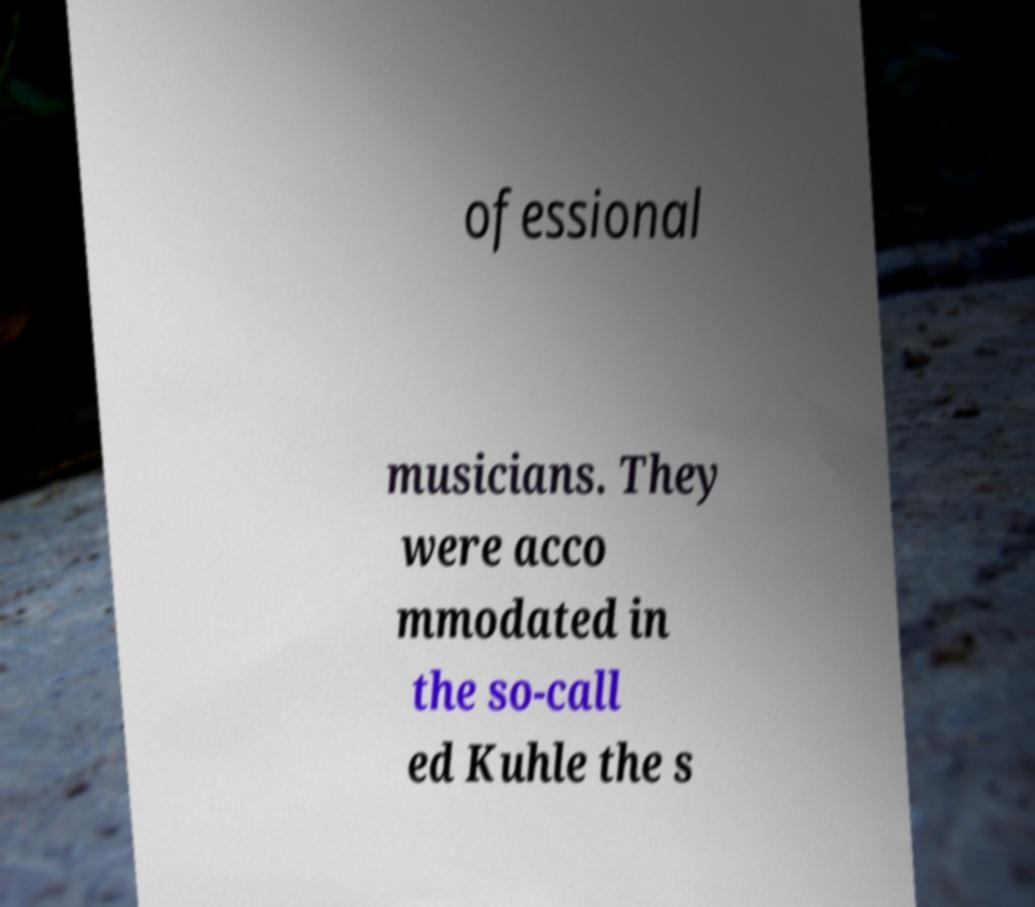There's text embedded in this image that I need extracted. Can you transcribe it verbatim? ofessional musicians. They were acco mmodated in the so-call ed Kuhle the s 